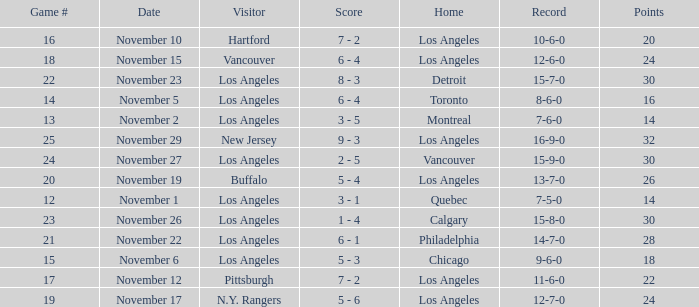What is the number of points of the game less than number 17 with an 11-6-0 record? None. 